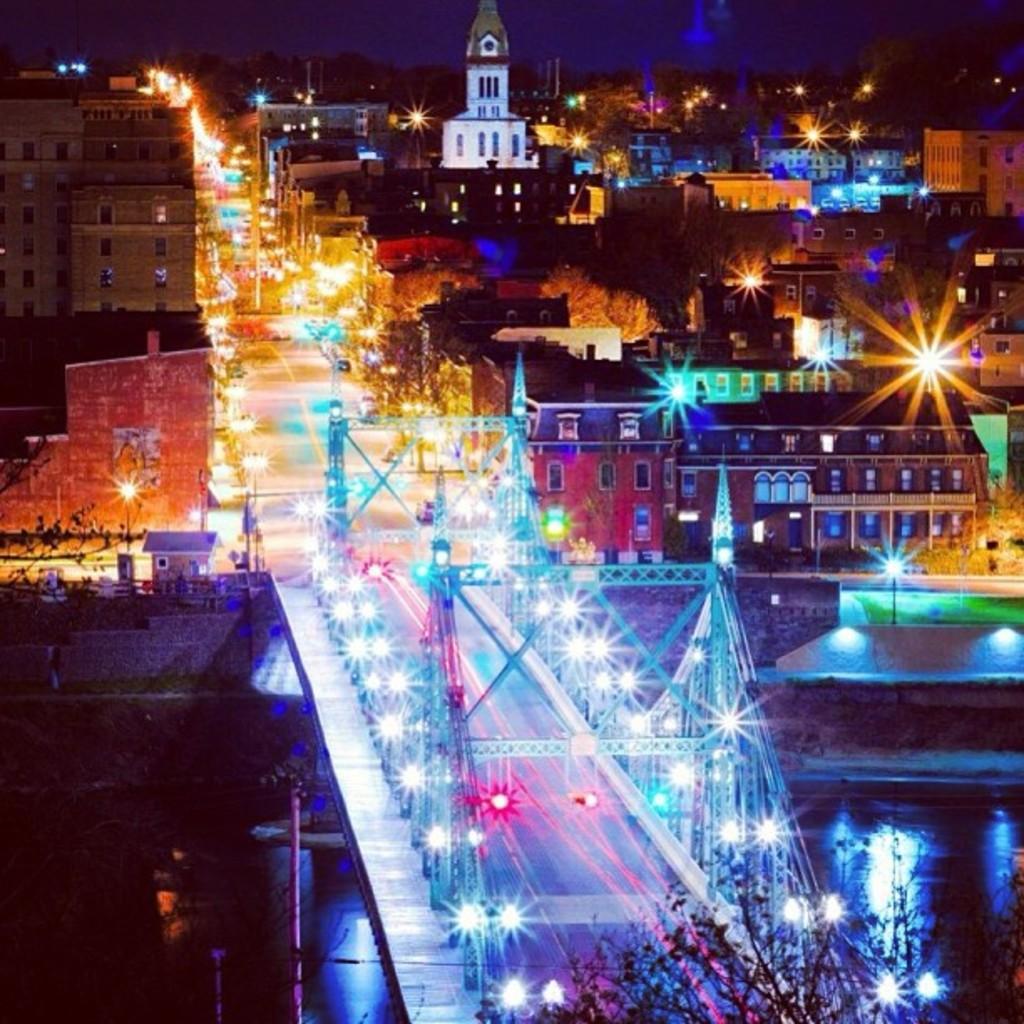How would you summarize this image in a sentence or two? In this image, we can see an aerial view of a city. In this image, in the middle, we can see a bridge with lights and poles. On the right side, we can see some houses, buildings, towers, trees and lights. On the left side, we can see some buildings, window, lights. In the left corner, we can also see black color. In the background, we can see some trees, sky, at the bottom, we can see a plant. 